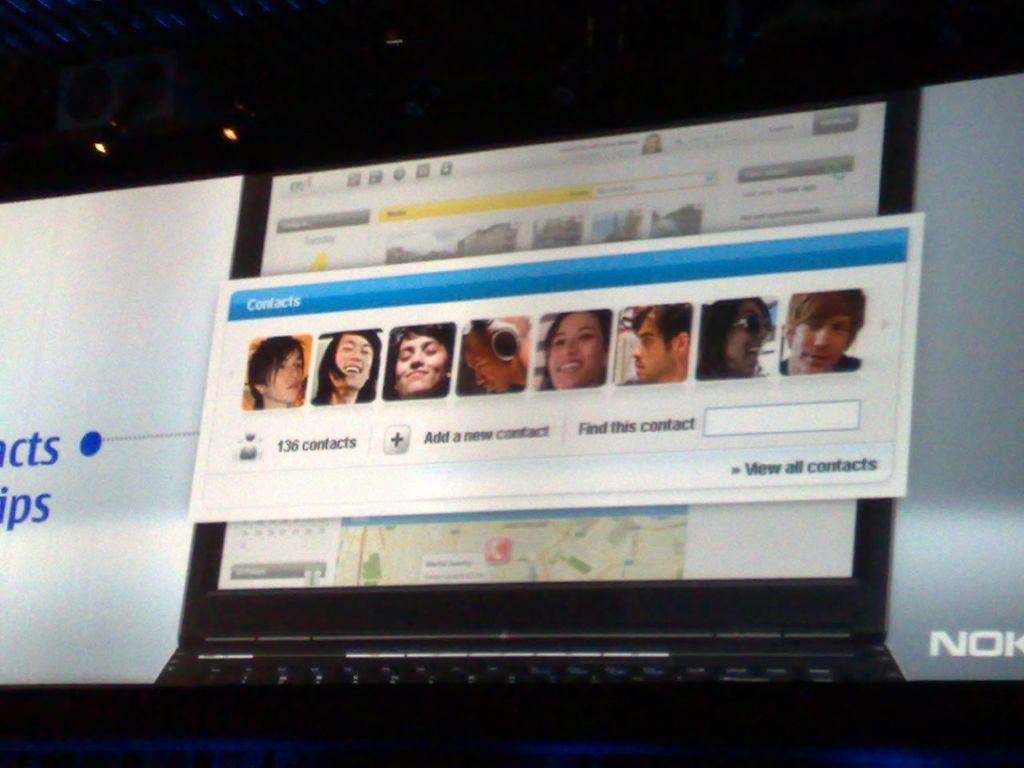<image>
Render a clear and concise summary of the photo. a computer screen that shows 136 contacts as a label on it 